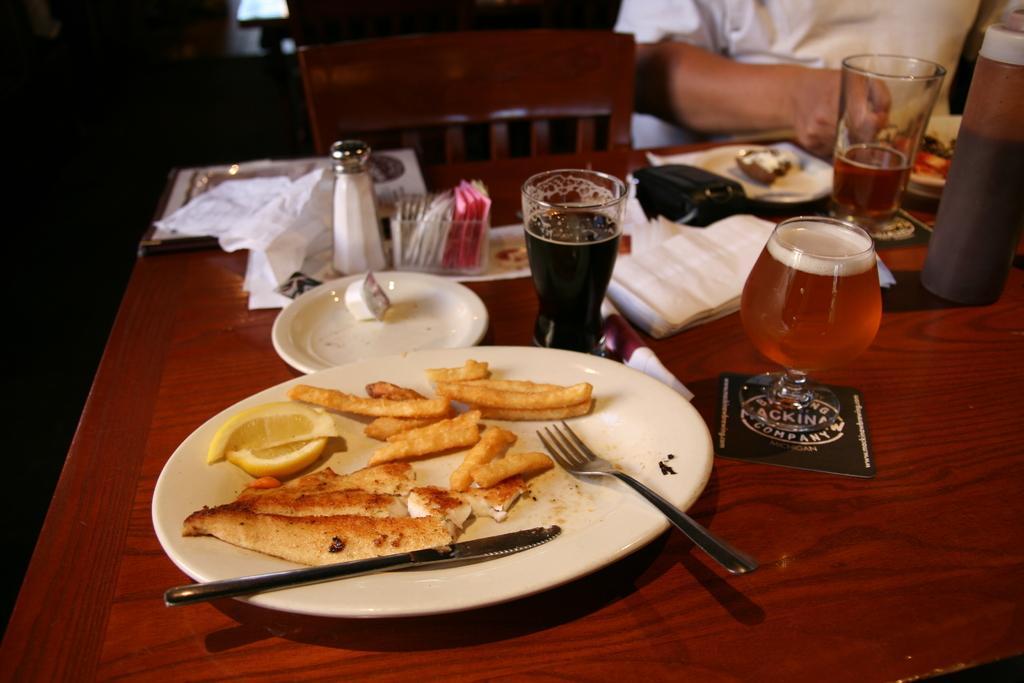Please provide a concise description of this image. There are food items on the plate and knife and fork and wine in a wine glass. A man is eating the food in a plate by sitting on the chair. in the left it's a salt bottle. 